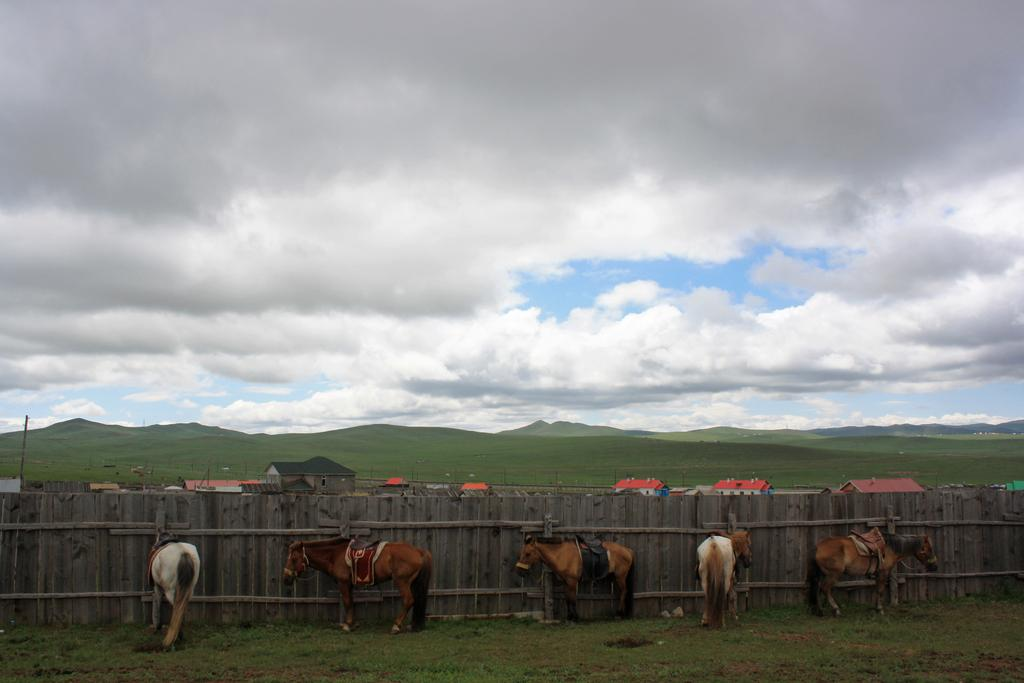What animals are present in the image? There are horses standing on the ground in the image. What type of barrier can be seen in the image? There is a wooden fence in the image. What structures are visible in the image? There are buildings in the image. What type of terrain is visible in the image? There are hills in the image. What is visible in the sky in the image? The sky is visible in the image, with clouds present. What impulse might have caused the horses to gather in the image? There is no information provided about the horses' behavior or any impulses that might have caused them to gather in the image. --- Facts: 1. There is a person holding a camera in the image. 2. The person is standing on a bridge. 3. There is a river flowing beneath the bridge. 4. There are trees on both sides of the river. 5. The sky is visible in the image, with a sunset visible. Absurd Topics: dance, robot, ocean Conversation: What is the person in the image holding? The person in the image is holding a camera. Where is the person standing in the image? The person is standing on a bridge. What is flowing beneath the bridge in the image? There is a river flowing beneath the bridge in the image. What type of vegetation is visible on both sides of the river? There are trees on both sides of the river in the image. What is visible in the sky in the image? The sky is visible in the image, with a sunset visible. Reasoning: Let's think step by step in order to produce the conversation. We start by identifying the main subject in the image, which is the person holding a camera. Then, we expand the conversation to include other elements of the image, such as the bridge, river, trees, and the sky with a sunset. Each question is designed to elicit a specific detail about the image that is known from the provided facts. Absurd Question/Answer: 